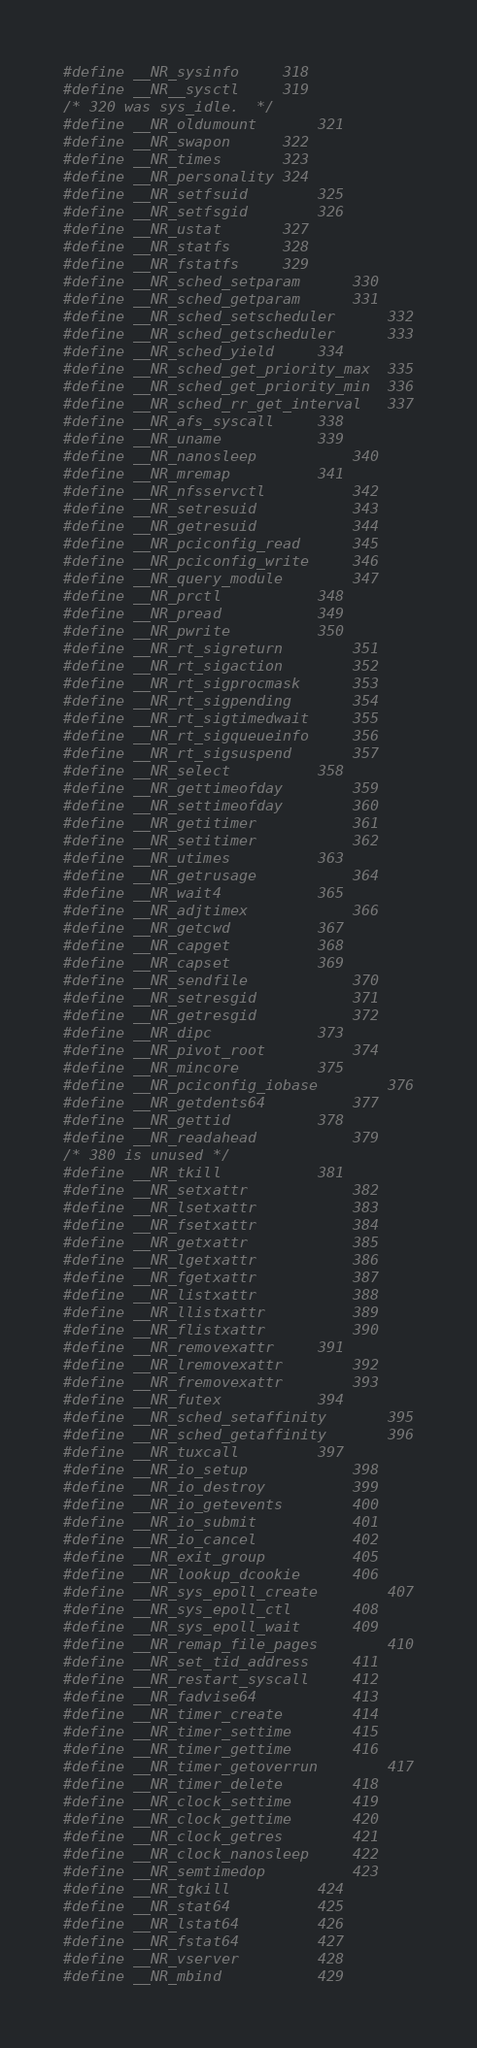Convert code to text. <code><loc_0><loc_0><loc_500><loc_500><_C_>#define __NR_sysinfo		318
#define __NR__sysctl		319
/* 320 was sys_idle.  */
#define __NR_oldumount		321
#define __NR_swapon		322
#define __NR_times		323
#define __NR_personality	324
#define __NR_setfsuid		325
#define __NR_setfsgid		326
#define __NR_ustat		327
#define __NR_statfs		328
#define __NR_fstatfs		329
#define __NR_sched_setparam		330
#define __NR_sched_getparam		331
#define __NR_sched_setscheduler		332
#define __NR_sched_getscheduler		333
#define __NR_sched_yield		334
#define __NR_sched_get_priority_max	335
#define __NR_sched_get_priority_min	336
#define __NR_sched_rr_get_interval	337
#define __NR_afs_syscall		338
#define __NR_uname			339
#define __NR_nanosleep			340
#define __NR_mremap			341
#define __NR_nfsservctl			342
#define __NR_setresuid			343
#define __NR_getresuid			344
#define __NR_pciconfig_read		345
#define __NR_pciconfig_write		346
#define __NR_query_module		347
#define __NR_prctl			348
#define __NR_pread			349
#define __NR_pwrite			350
#define __NR_rt_sigreturn		351
#define __NR_rt_sigaction		352
#define __NR_rt_sigprocmask		353
#define __NR_rt_sigpending		354
#define __NR_rt_sigtimedwait		355
#define __NR_rt_sigqueueinfo		356
#define __NR_rt_sigsuspend		357
#define __NR_select			358
#define __NR_gettimeofday		359
#define __NR_settimeofday		360
#define __NR_getitimer			361
#define __NR_setitimer			362
#define __NR_utimes			363
#define __NR_getrusage			364
#define __NR_wait4			365
#define __NR_adjtimex			366
#define __NR_getcwd			367
#define __NR_capget			368
#define __NR_capset			369
#define __NR_sendfile			370
#define __NR_setresgid			371
#define __NR_getresgid			372
#define __NR_dipc			373
#define __NR_pivot_root			374
#define __NR_mincore			375
#define __NR_pciconfig_iobase		376
#define __NR_getdents64			377
#define __NR_gettid			378
#define __NR_readahead			379
/* 380 is unused */
#define __NR_tkill			381
#define __NR_setxattr			382
#define __NR_lsetxattr			383
#define __NR_fsetxattr			384
#define __NR_getxattr			385
#define __NR_lgetxattr			386
#define __NR_fgetxattr			387
#define __NR_listxattr			388
#define __NR_llistxattr			389
#define __NR_flistxattr			390
#define __NR_removexattr		391
#define __NR_lremovexattr		392
#define __NR_fremovexattr		393
#define __NR_futex			394
#define __NR_sched_setaffinity		395
#define __NR_sched_getaffinity		396
#define __NR_tuxcall			397
#define __NR_io_setup			398
#define __NR_io_destroy			399
#define __NR_io_getevents		400
#define __NR_io_submit			401
#define __NR_io_cancel			402
#define __NR_exit_group			405
#define __NR_lookup_dcookie		406
#define __NR_sys_epoll_create		407
#define __NR_sys_epoll_ctl		408
#define __NR_sys_epoll_wait		409
#define __NR_remap_file_pages		410
#define __NR_set_tid_address		411
#define __NR_restart_syscall		412
#define __NR_fadvise64			413
#define __NR_timer_create		414
#define __NR_timer_settime		415
#define __NR_timer_gettime		416
#define __NR_timer_getoverrun		417
#define __NR_timer_delete		418
#define __NR_clock_settime		419
#define __NR_clock_gettime		420
#define __NR_clock_getres		421
#define __NR_clock_nanosleep		422
#define __NR_semtimedop			423
#define __NR_tgkill			424
#define __NR_stat64			425
#define __NR_lstat64			426
#define __NR_fstat64			427
#define __NR_vserver			428
#define __NR_mbind			429</code> 